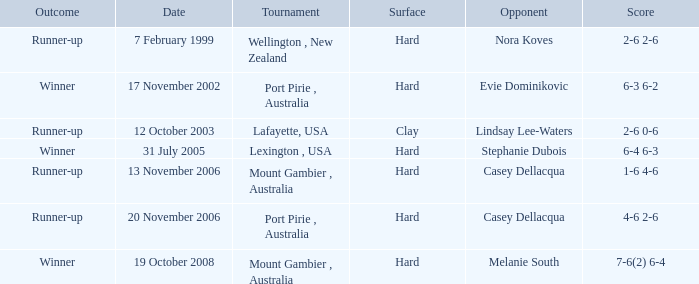Which Score has an Opponent of melanie south? 7-6(2) 6-4. 